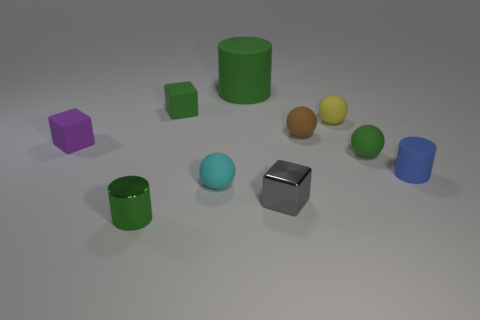Subtract all brown spheres. How many spheres are left? 3 Subtract all cyan balls. How many balls are left? 3 Subtract all gray balls. Subtract all blue cubes. How many balls are left? 4 Subtract all spheres. How many objects are left? 6 Add 4 small green rubber cubes. How many small green rubber cubes are left? 5 Add 10 big brown cylinders. How many big brown cylinders exist? 10 Subtract 0 gray balls. How many objects are left? 10 Subtract all matte cylinders. Subtract all tiny gray cylinders. How many objects are left? 8 